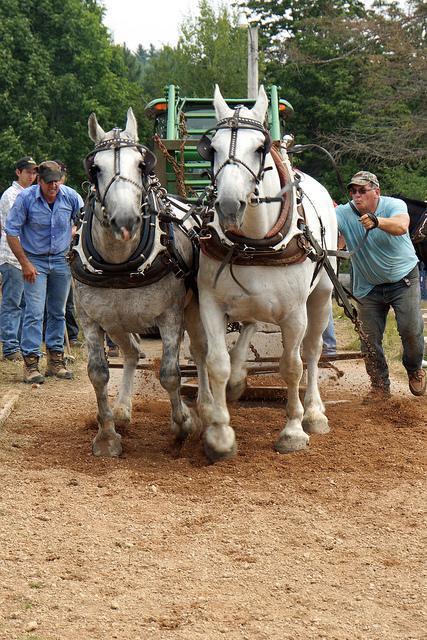How many horses are pulling the cart?
Give a very brief answer. 2. How many people are in the photo?
Give a very brief answer. 3. How many horses are in the photo?
Give a very brief answer. 2. How many cats are in this picture?
Give a very brief answer. 0. 